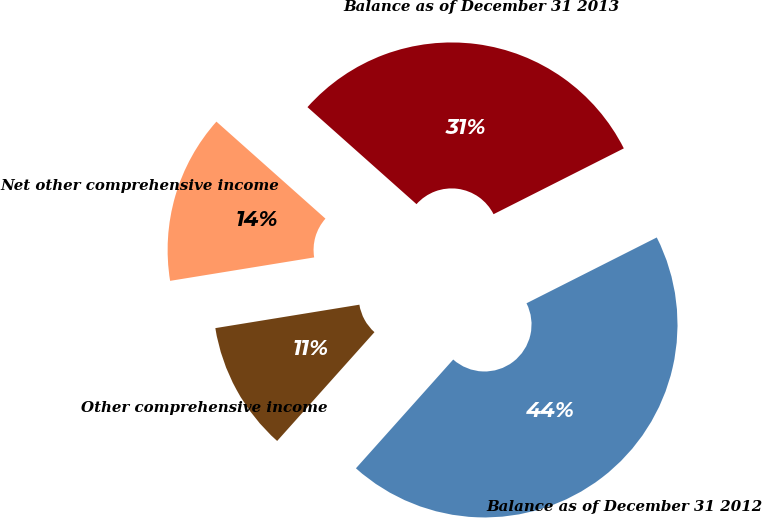Convert chart to OTSL. <chart><loc_0><loc_0><loc_500><loc_500><pie_chart><fcel>Balance as of December 31 2012<fcel>Other comprehensive income<fcel>Net other comprehensive income<fcel>Balance as of December 31 2013<nl><fcel>44.06%<fcel>10.82%<fcel>14.14%<fcel>30.98%<nl></chart> 